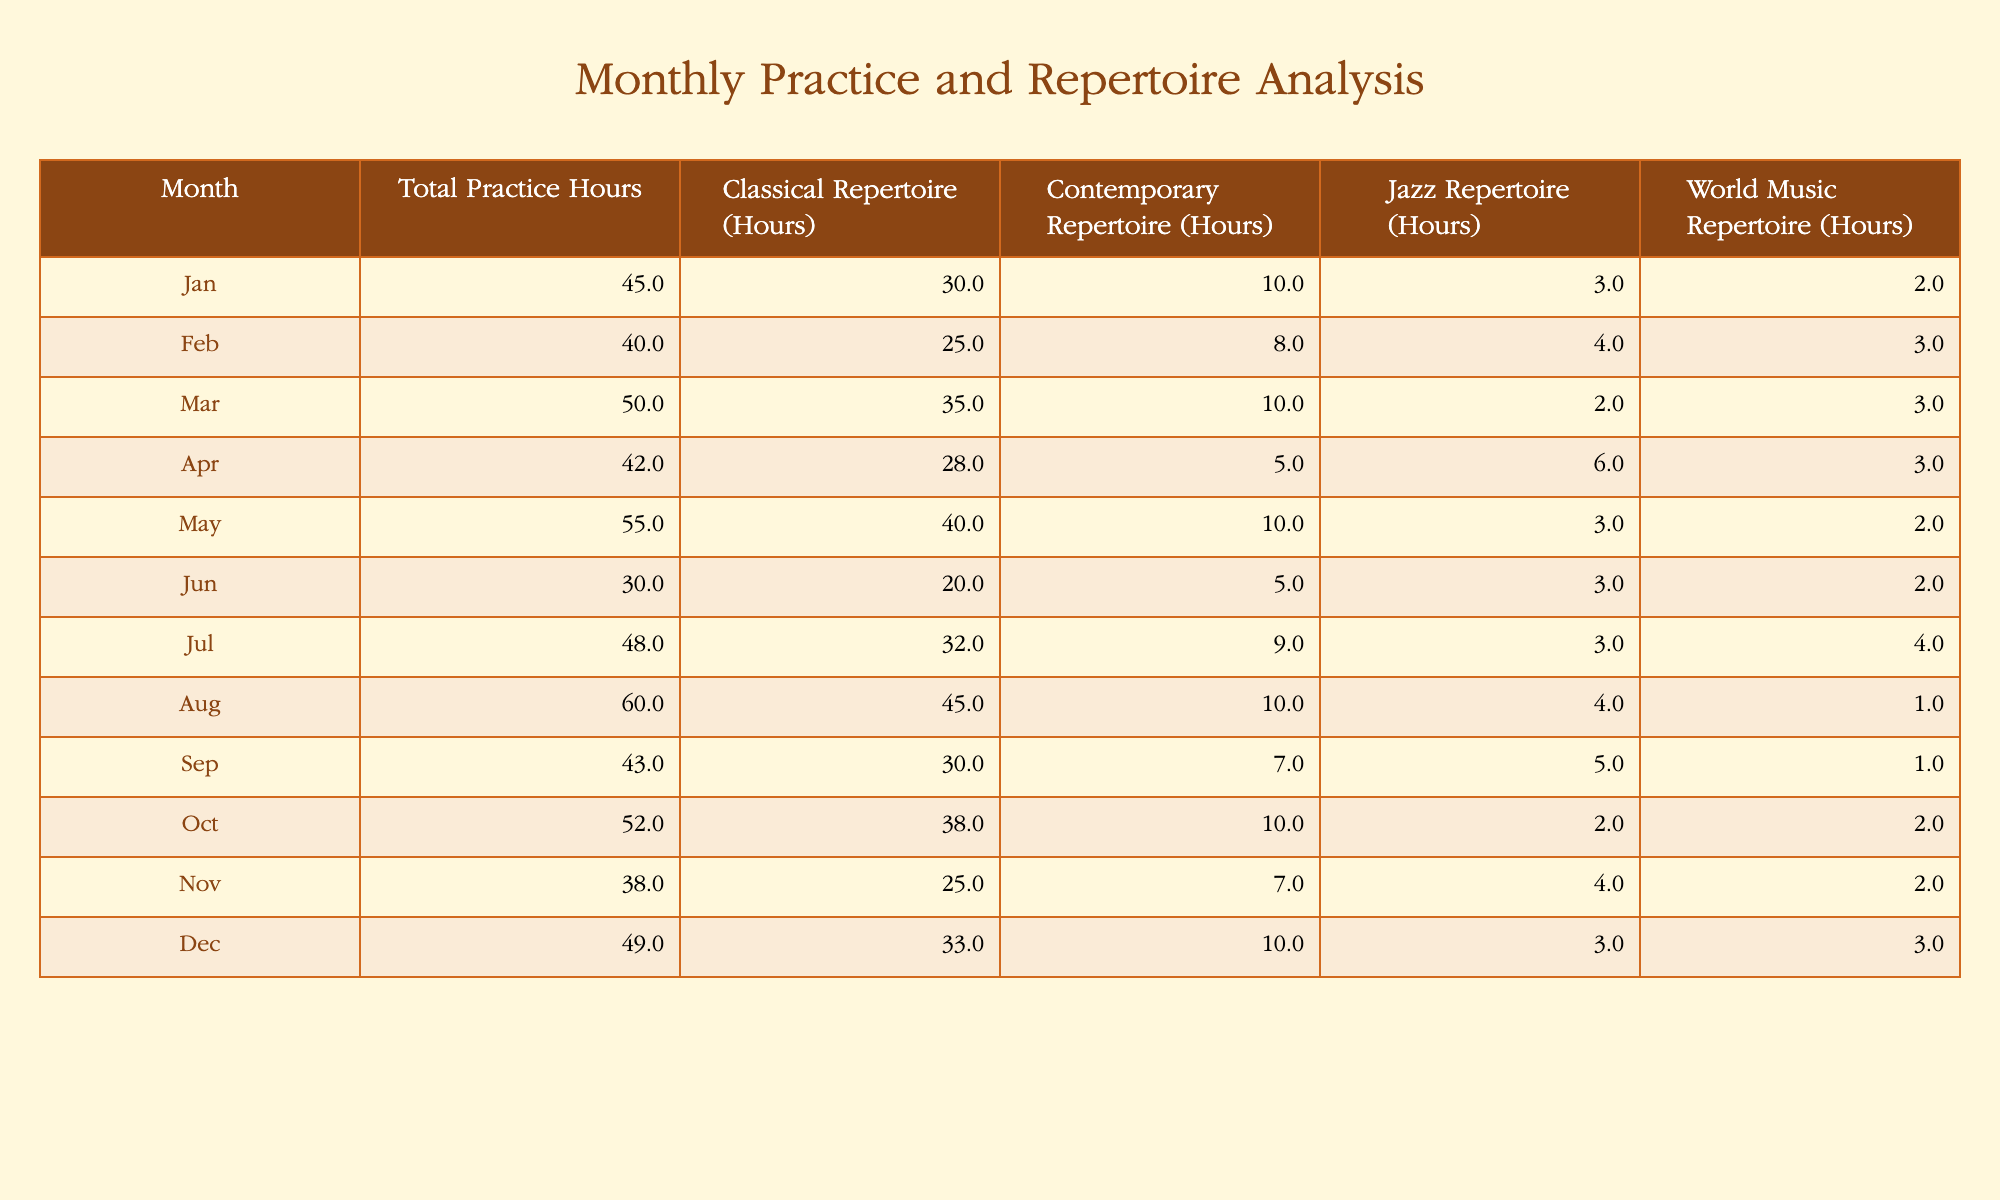What is the total number of practice hours recorded in March? In March, the table indicates that the total practice hours are listed directly under the "Total Practice Hours" column for that month. By checking the row for March, I find 50 hours.
Answer: 50 What is the average number of classical repertoire hours practiced per month? To find the average, I add up the classical repertoire hours from January to December: (30 + 25 + 35 + 28 + 40 + 20 + 32 + 45 + 30 + 38 + 25 + 33) =  417. Dividing this total by 12 gives an average of 417 / 12 = 34.75 hours.
Answer: 34.75 In which month did the least number of world music repertoire hours practiced, and what was that amount? By scanning the "World Music Repertoire (Hours)" column, I look for the minimum value. I see the least hours recorded is 1 hour in August.
Answer: August, 1 Is the total number of contemporary repertoire hours greater than 100 across the entire year? First, I need to sum the contemporary hours from each month: (10 + 8 + 10 + 5 + 10 + 5 + 9 + 10 + 7 + 10 + 7 + 10) = 99. Since 99 is less than 100, the statement is false.
Answer: No Which month has the highest diversity in repertoire hours, considering all categories? To determine the month with the highest diversity, I sum the hours across all repertoire types for each month and compare. The calculations show: January (45), February (40), March (50), April (42), May (55), June (30), July (48), August (60), September (43), October (52), November (38), December (49). The highest total is for August with 60 hours.
Answer: August Was there a month where more hours were devoted to jazz repertoire than world music repertoire? By comparing the hours from each month for the jazz and world music categories, I find that in this data, every month had more contemporary hours than world music, confirming that in multiple instances, such as January (3 vs. 2), this is true.
Answer: Yes What is the difference in total practice hours between May and December? First, I find the total practice hours for May (55 hours) and December (49 hours). The difference is calculated as 55 - 49 = 6.
Answer: 6 What percentage of the total hours in July were dedicated to classical repertoire? In July, the total practice hours recorded is 48 and the classical hours are 32. The percentage is calculated as (32 / 48) x 100 = 66.67%.
Answer: 66.67% 